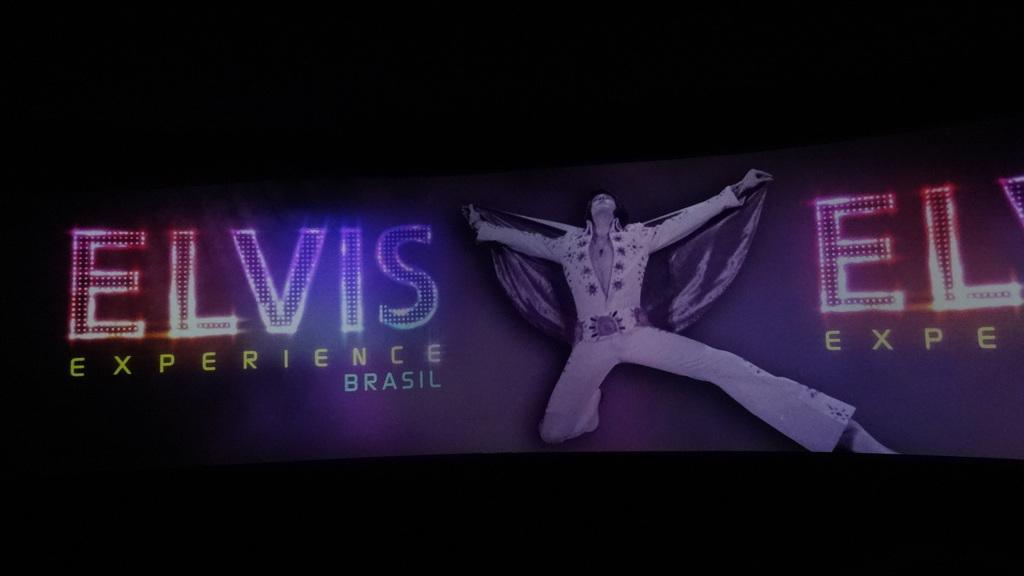Can you describe this image briefly? In this image I can see a man and something written on it. 